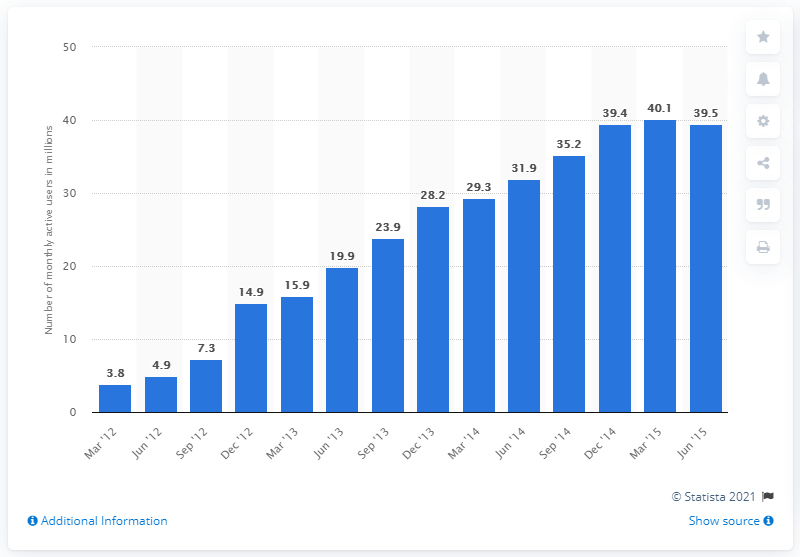Identify some key points in this picture. In June 2015, there were approximately 39.5 monthly active Viki users. 